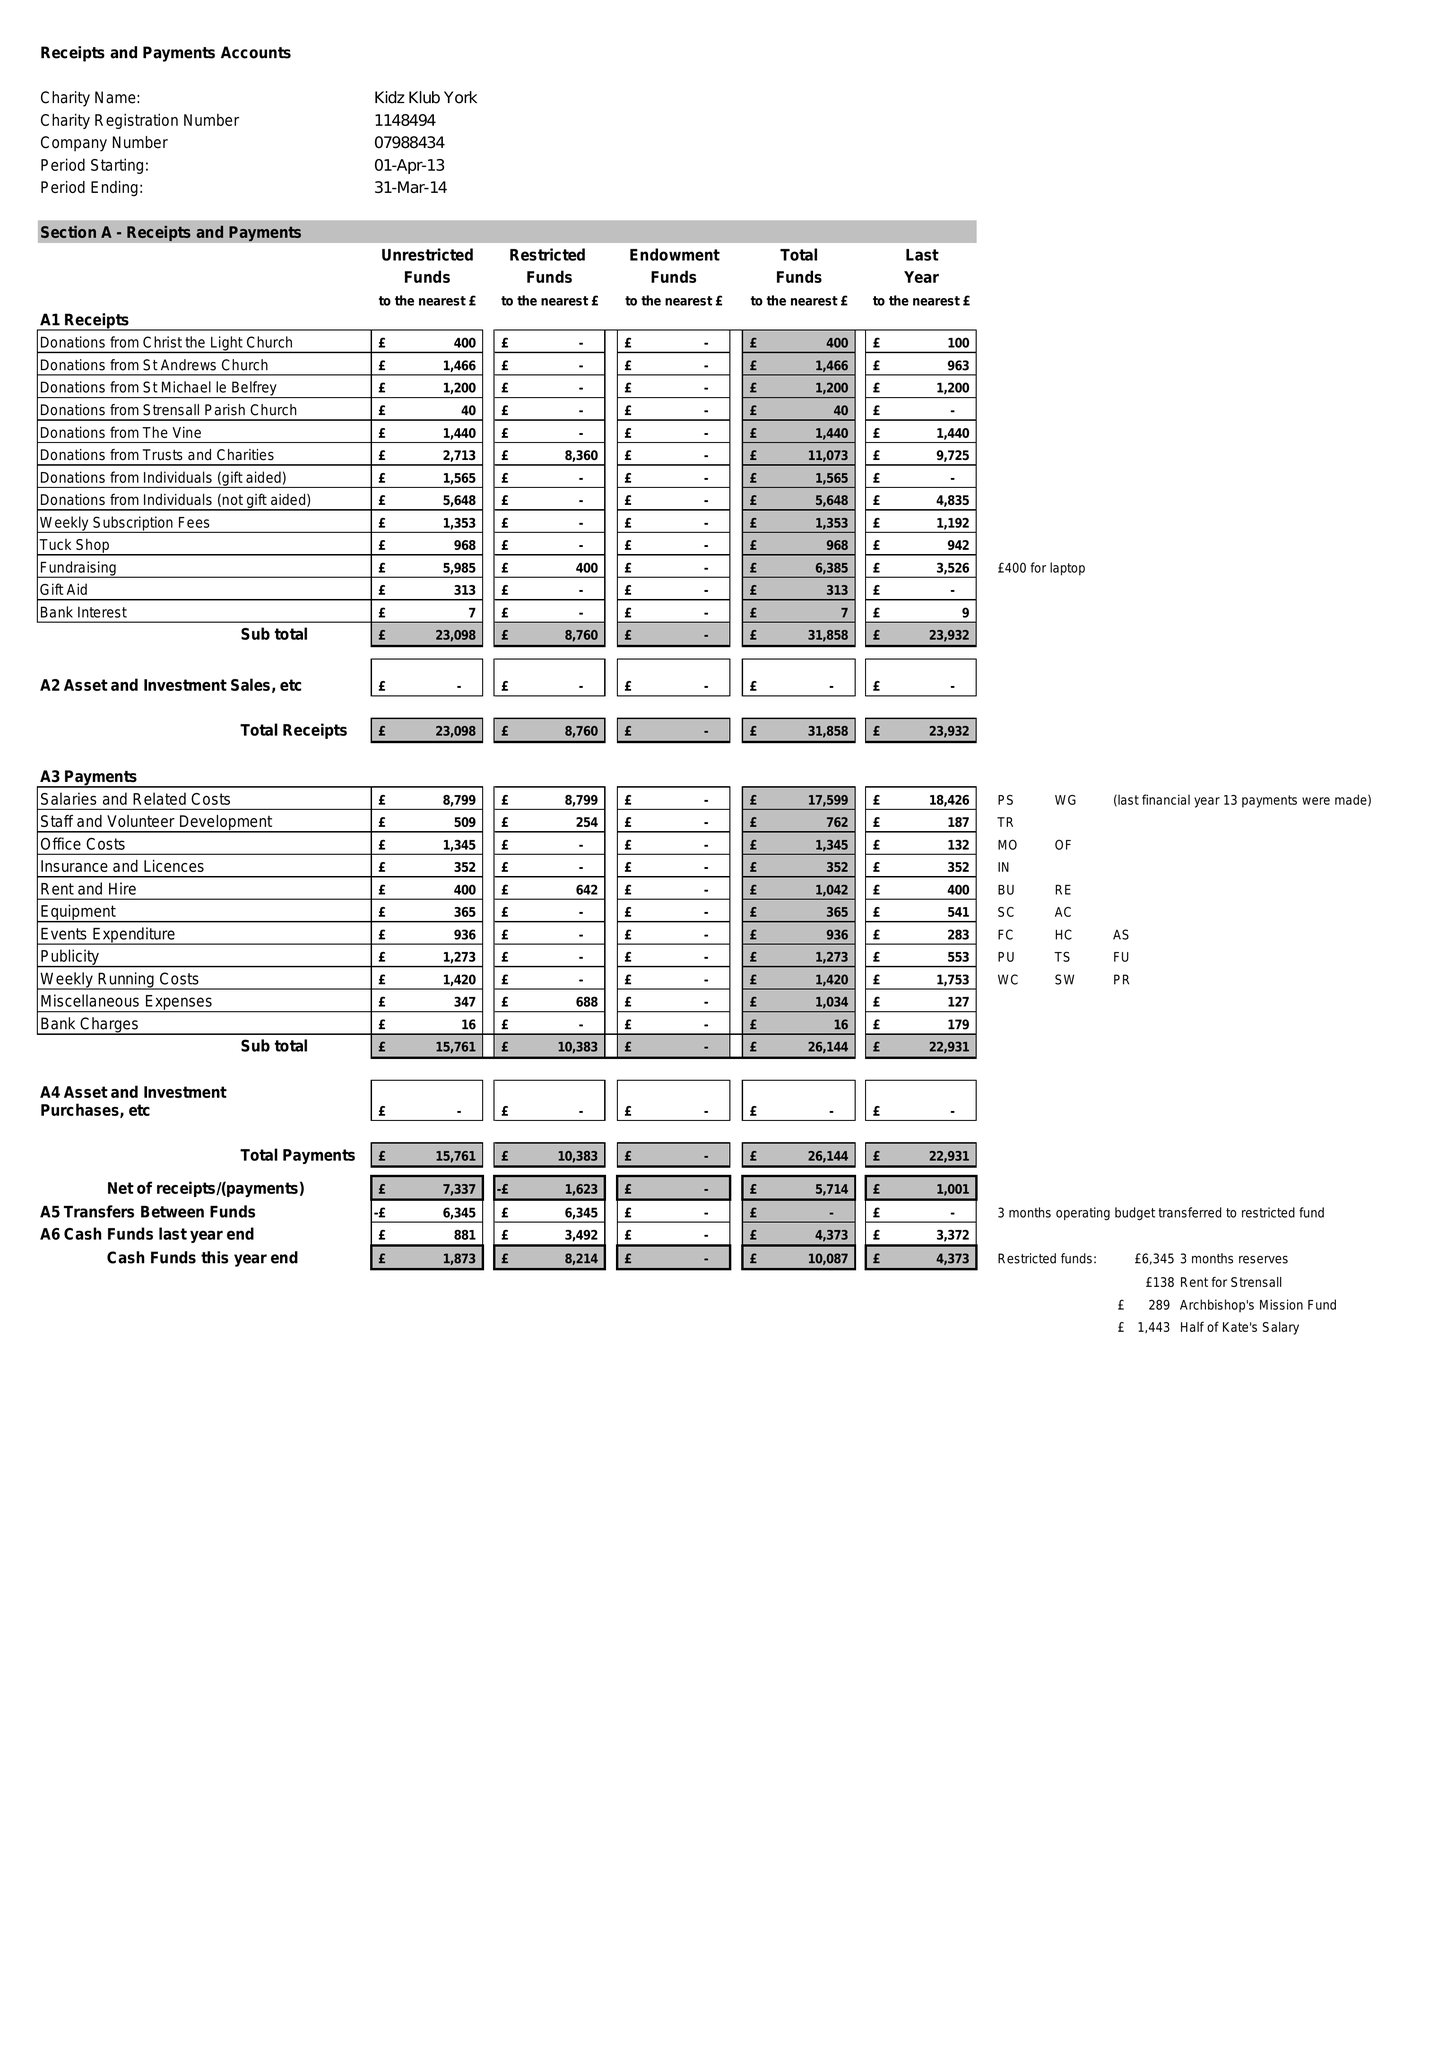What is the value for the address__street_line?
Answer the question using a single word or phrase. HUNTINGTON ROAD 